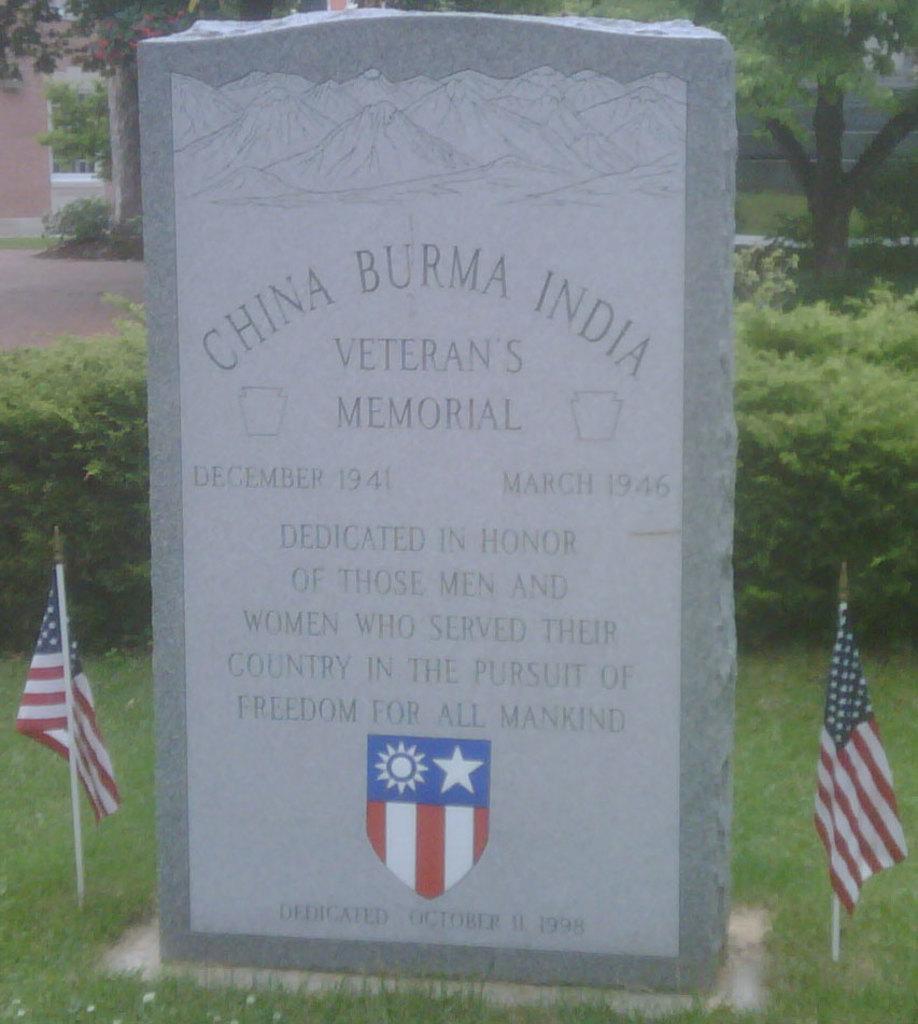How would you summarize this image in a sentence or two? In this image I can see grass ground in the front and on it I can see a tombstone. I can also see something is written on it and on the both side of it I can see two flags. In the background I can see plants, few trees and few buildings. 